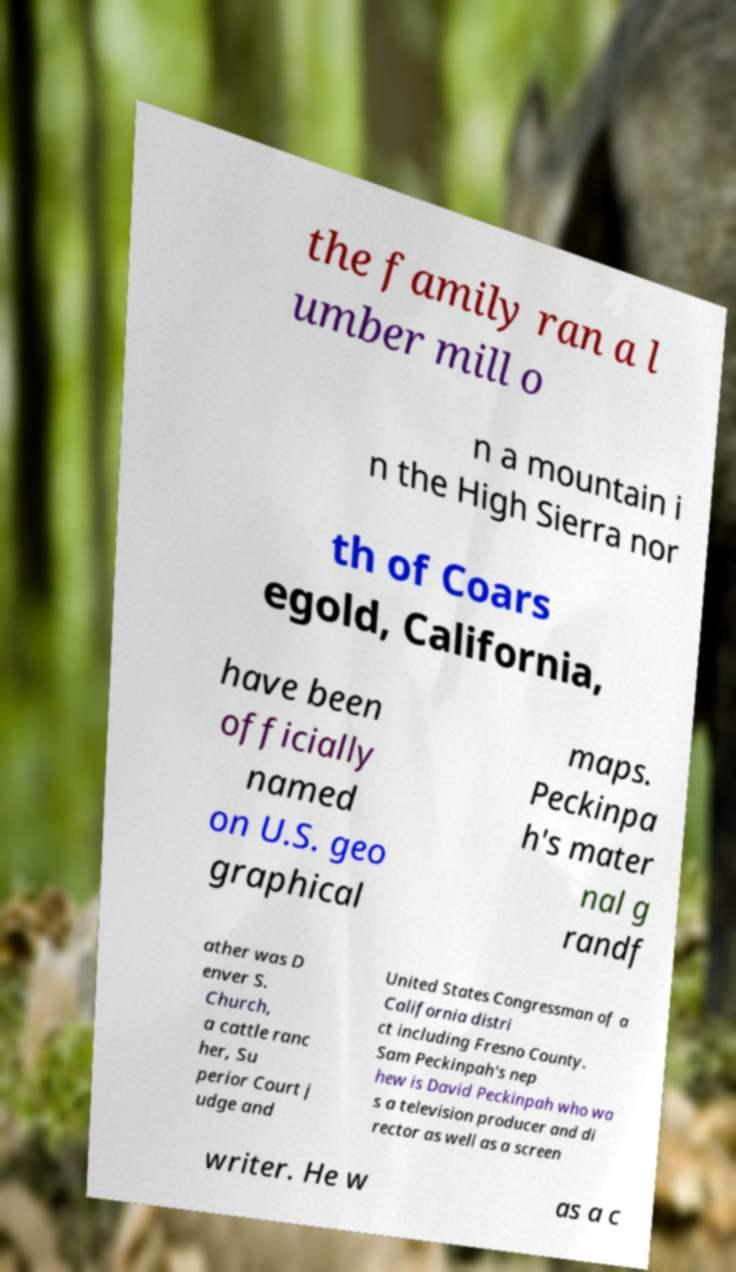There's text embedded in this image that I need extracted. Can you transcribe it verbatim? the family ran a l umber mill o n a mountain i n the High Sierra nor th of Coars egold, California, have been officially named on U.S. geo graphical maps. Peckinpa h's mater nal g randf ather was D enver S. Church, a cattle ranc her, Su perior Court j udge and United States Congressman of a California distri ct including Fresno County. Sam Peckinpah's nep hew is David Peckinpah who wa s a television producer and di rector as well as a screen writer. He w as a c 